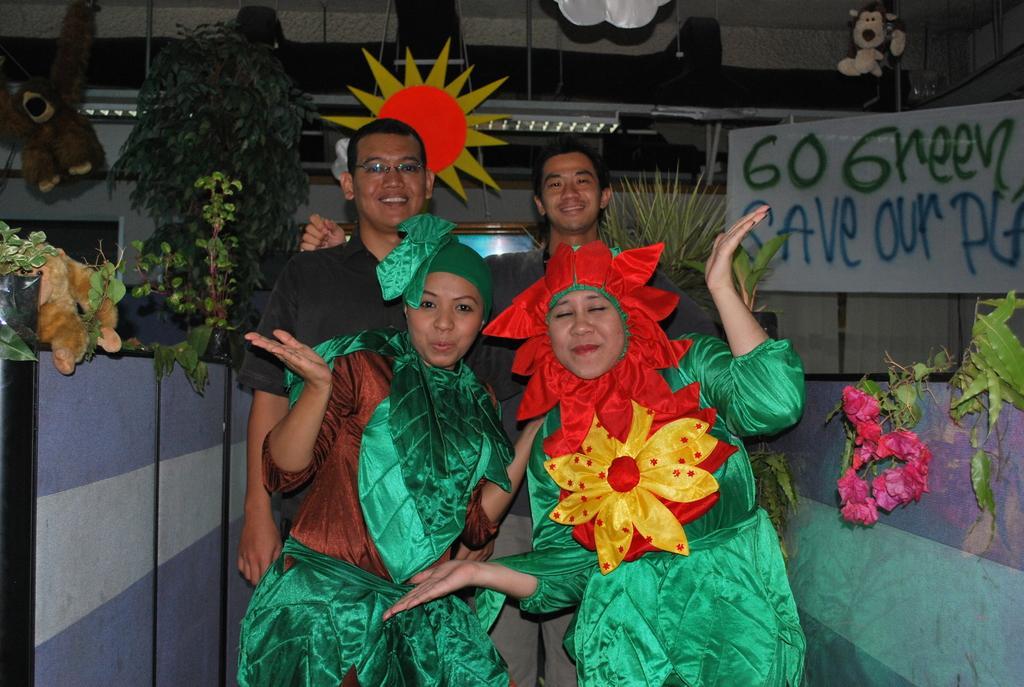Can you describe this image briefly? In this picture I can see two women wearing the costumes, behind them two men are smiling. there are plants and dolls on either side of this image. 